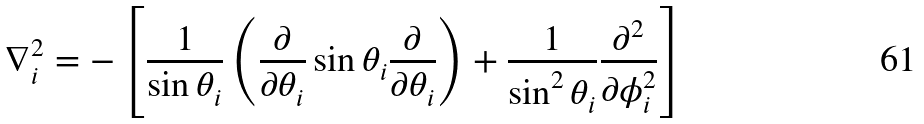<formula> <loc_0><loc_0><loc_500><loc_500>\nabla _ { i } ^ { 2 } = - \left [ \frac { 1 } { \sin \theta _ { i } } \left ( \frac { \partial } { \partial \theta _ { i } } \sin \theta _ { i } \frac { \partial } { \partial \theta _ { i } } \right ) + \frac { 1 } { \sin ^ { 2 } \theta _ { i } } \frac { \partial ^ { 2 } } { \partial \phi _ { i } ^ { 2 } } \right ]</formula> 